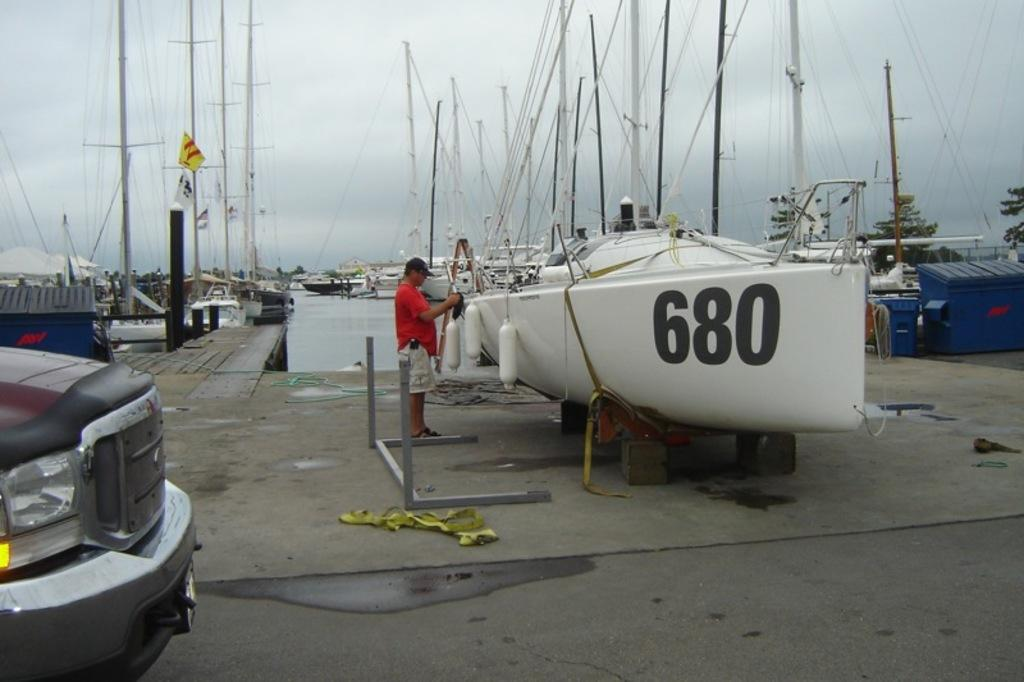What is the person in the image standing beside? The person is standing beside a boat. What can be seen on the left side of the image? There is a vehicle and poles on the left side of the image. What is visible on the water in the image? There are boats on the water. What is present on the right side of the image? There are trees and bins on the right side of the image, as well as a pole. What type of bag is the person holding in the image? There is no bag visible in the image; the person is standing beside a boat. Can you tell me how many times the person in the image ground their teeth? There is no indication of the person grinding their teeth in the image, and therefore this cannot be determined. 